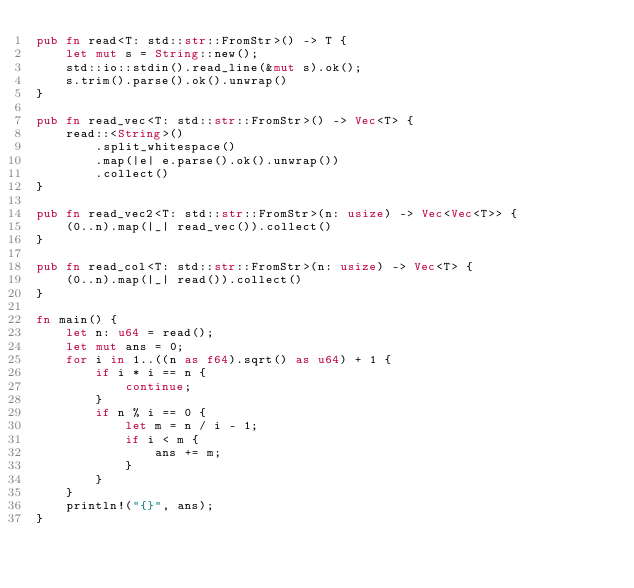Convert code to text. <code><loc_0><loc_0><loc_500><loc_500><_Rust_>pub fn read<T: std::str::FromStr>() -> T {
    let mut s = String::new();
    std::io::stdin().read_line(&mut s).ok();
    s.trim().parse().ok().unwrap()
}

pub fn read_vec<T: std::str::FromStr>() -> Vec<T> {
    read::<String>()
        .split_whitespace()
        .map(|e| e.parse().ok().unwrap())
        .collect()
}

pub fn read_vec2<T: std::str::FromStr>(n: usize) -> Vec<Vec<T>> {
    (0..n).map(|_| read_vec()).collect()
}

pub fn read_col<T: std::str::FromStr>(n: usize) -> Vec<T> {
    (0..n).map(|_| read()).collect()
}

fn main() {
    let n: u64 = read();
    let mut ans = 0;
    for i in 1..((n as f64).sqrt() as u64) + 1 {
        if i * i == n {
            continue;
        }
        if n % i == 0 {
            let m = n / i - 1;
            if i < m {
                ans += m;
            }
        }
    }
    println!("{}", ans);
}
</code> 